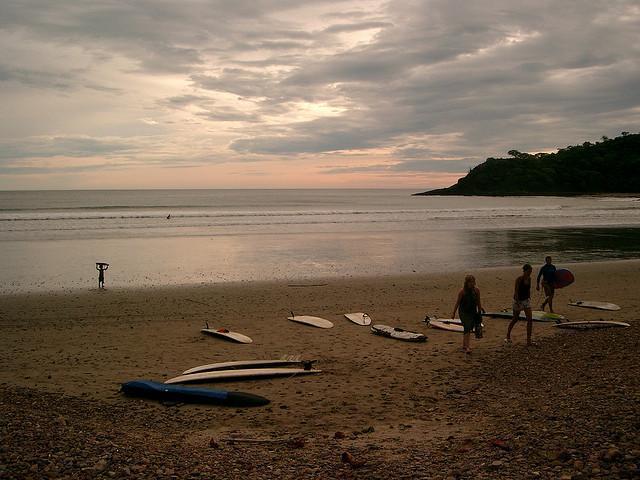How many orange balloons are in the picture?
Give a very brief answer. 0. 